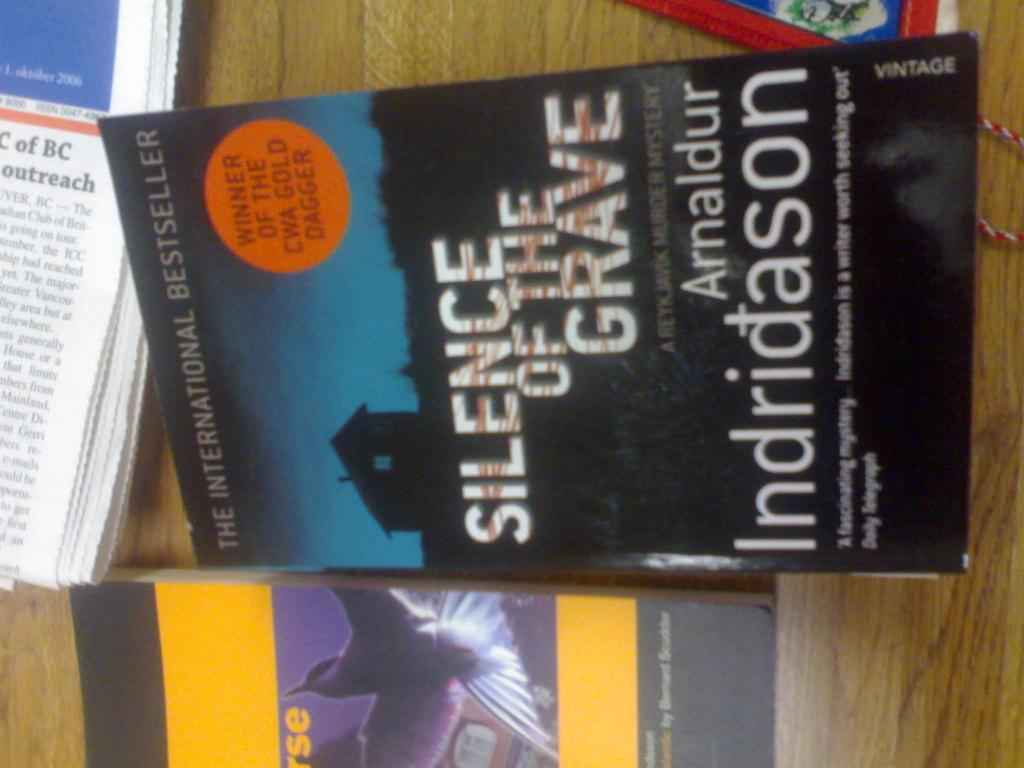<image>
Offer a succinct explanation of the picture presented. A wooden table with several books on it including one called Silence of the Grave. 